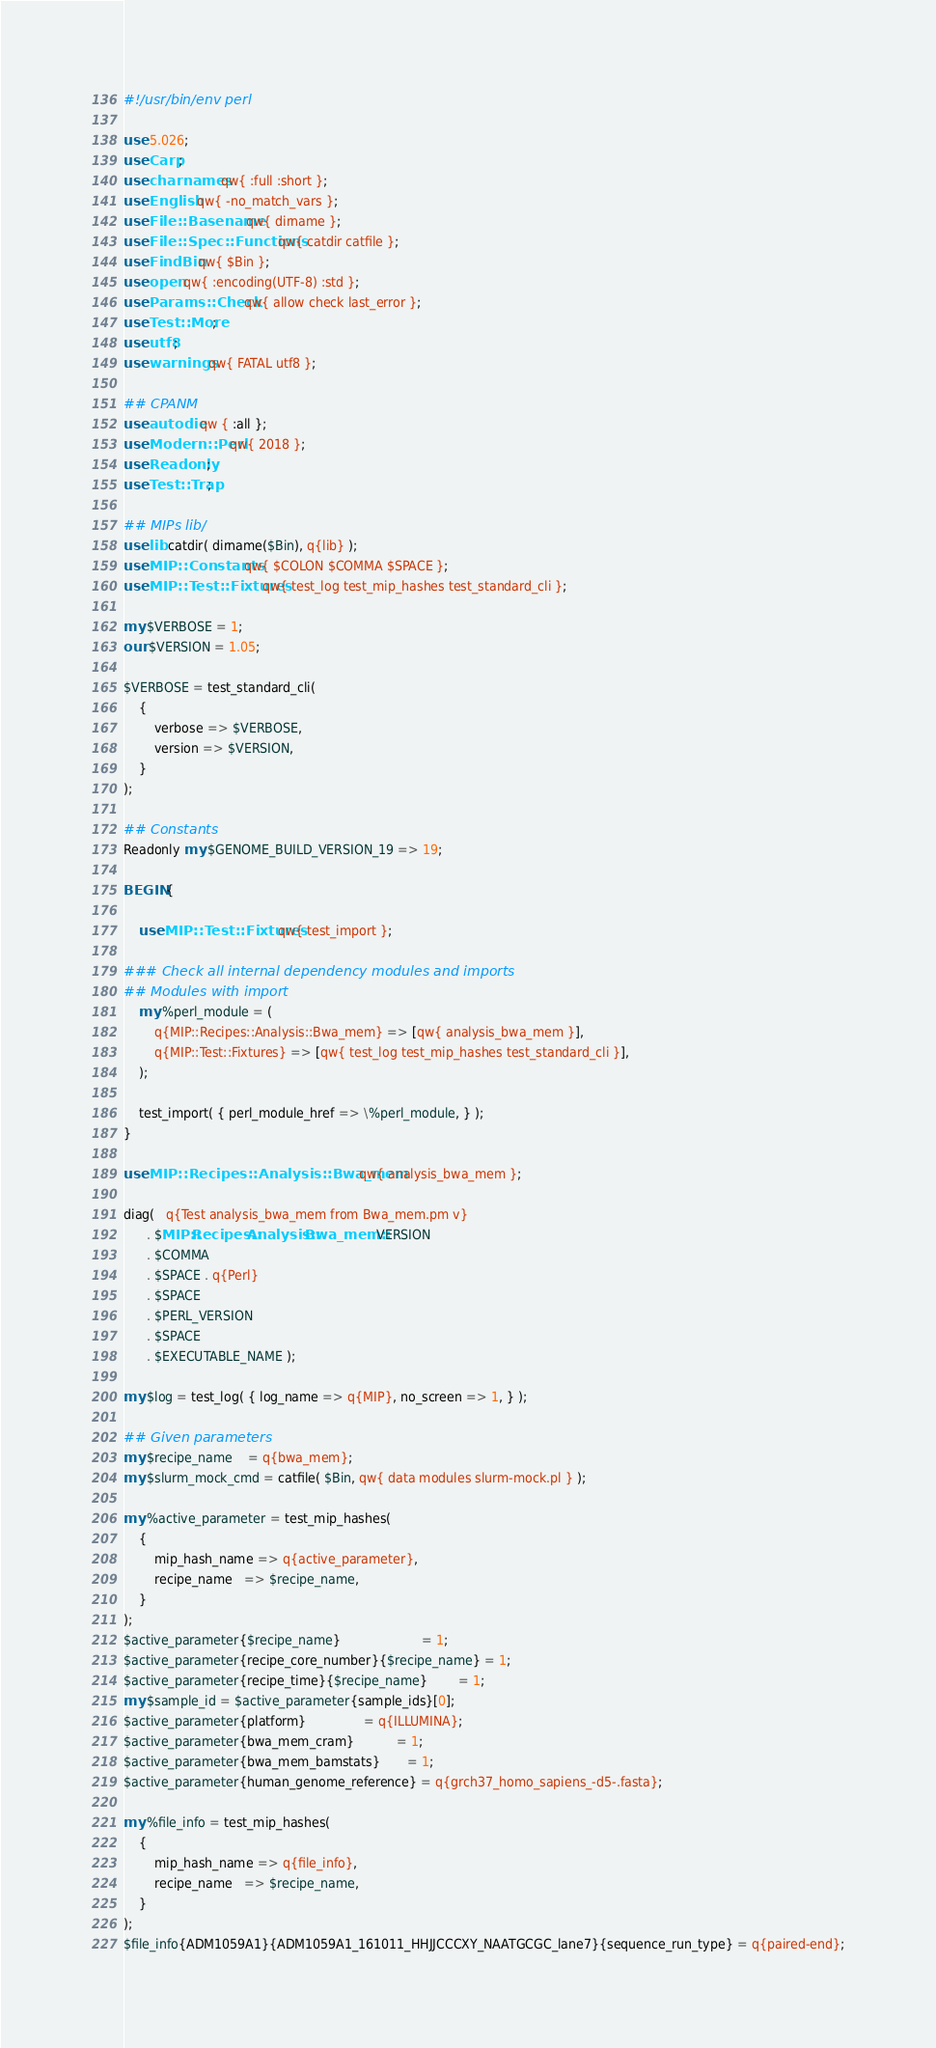<code> <loc_0><loc_0><loc_500><loc_500><_Perl_>#!/usr/bin/env perl

use 5.026;
use Carp;
use charnames qw{ :full :short };
use English qw{ -no_match_vars };
use File::Basename qw{ dirname };
use File::Spec::Functions qw{ catdir catfile };
use FindBin qw{ $Bin };
use open qw{ :encoding(UTF-8) :std };
use Params::Check qw{ allow check last_error };
use Test::More;
use utf8;
use warnings qw{ FATAL utf8 };

## CPANM
use autodie qw { :all };
use Modern::Perl qw{ 2018 };
use Readonly;
use Test::Trap;

## MIPs lib/
use lib catdir( dirname($Bin), q{lib} );
use MIP::Constants qw{ $COLON $COMMA $SPACE };
use MIP::Test::Fixtures qw{ test_log test_mip_hashes test_standard_cli };

my $VERBOSE = 1;
our $VERSION = 1.05;

$VERBOSE = test_standard_cli(
    {
        verbose => $VERBOSE,
        version => $VERSION,
    }
);

## Constants
Readonly my $GENOME_BUILD_VERSION_19 => 19;

BEGIN {

    use MIP::Test::Fixtures qw{ test_import };

### Check all internal dependency modules and imports
## Modules with import
    my %perl_module = (
        q{MIP::Recipes::Analysis::Bwa_mem} => [qw{ analysis_bwa_mem }],
        q{MIP::Test::Fixtures} => [qw{ test_log test_mip_hashes test_standard_cli }],
    );

    test_import( { perl_module_href => \%perl_module, } );
}

use MIP::Recipes::Analysis::Bwa_mem qw{ analysis_bwa_mem };

diag(   q{Test analysis_bwa_mem from Bwa_mem.pm v}
      . $MIP::Recipes::Analysis::Bwa_mem::VERSION
      . $COMMA
      . $SPACE . q{Perl}
      . $SPACE
      . $PERL_VERSION
      . $SPACE
      . $EXECUTABLE_NAME );

my $log = test_log( { log_name => q{MIP}, no_screen => 1, } );

## Given parameters
my $recipe_name    = q{bwa_mem};
my $slurm_mock_cmd = catfile( $Bin, qw{ data modules slurm-mock.pl } );

my %active_parameter = test_mip_hashes(
    {
        mip_hash_name => q{active_parameter},
        recipe_name   => $recipe_name,
    }
);
$active_parameter{$recipe_name}                     = 1;
$active_parameter{recipe_core_number}{$recipe_name} = 1;
$active_parameter{recipe_time}{$recipe_name}        = 1;
my $sample_id = $active_parameter{sample_ids}[0];
$active_parameter{platform}               = q{ILLUMINA};
$active_parameter{bwa_mem_cram}           = 1;
$active_parameter{bwa_mem_bamstats}       = 1;
$active_parameter{human_genome_reference} = q{grch37_homo_sapiens_-d5-.fasta};

my %file_info = test_mip_hashes(
    {
        mip_hash_name => q{file_info},
        recipe_name   => $recipe_name,
    }
);
$file_info{ADM1059A1}{ADM1059A1_161011_HHJJCCCXY_NAATGCGC_lane7}{sequence_run_type} = q{paired-end};
</code> 